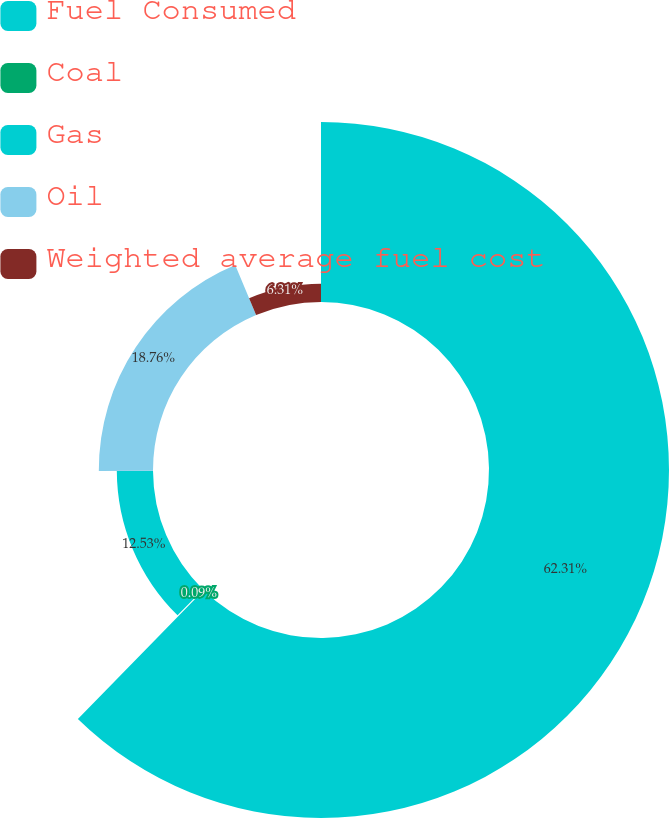<chart> <loc_0><loc_0><loc_500><loc_500><pie_chart><fcel>Fuel Consumed<fcel>Coal<fcel>Gas<fcel>Oil<fcel>Weighted average fuel cost<nl><fcel>62.31%<fcel>0.09%<fcel>12.53%<fcel>18.76%<fcel>6.31%<nl></chart> 